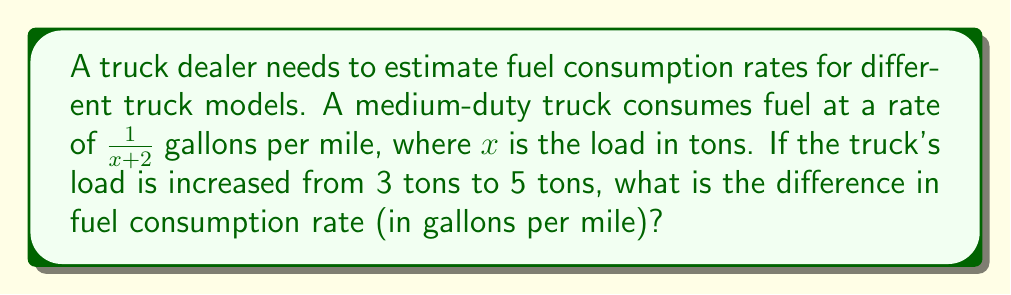Give your solution to this math problem. To solve this problem, we'll follow these steps:

1. Calculate the fuel consumption rate for a 3-ton load:
   $$\text{Rate}_3 = \frac{1}{3+2} = \frac{1}{5} \text{ gallons per mile}$$

2. Calculate the fuel consumption rate for a 5-ton load:
   $$\text{Rate}_5 = \frac{1}{5+2} = \frac{1}{7} \text{ gallons per mile}$$

3. Find the difference between the two rates:
   $$\text{Difference} = \text{Rate}_3 - \text{Rate}_5 = \frac{1}{5} - \frac{1}{7}$$

4. To subtract fractions with different denominators, we need a common denominator:
   $$\frac{1}{5} - \frac{1}{7} = \frac{7}{35} - \frac{5}{35} = \frac{2}{35} \text{ gallons per mile}$$

Therefore, the difference in fuel consumption rate when increasing the load from 3 tons to 5 tons is $\frac{2}{35}$ gallons per mile.
Answer: $\frac{2}{35}$ gallons per mile 